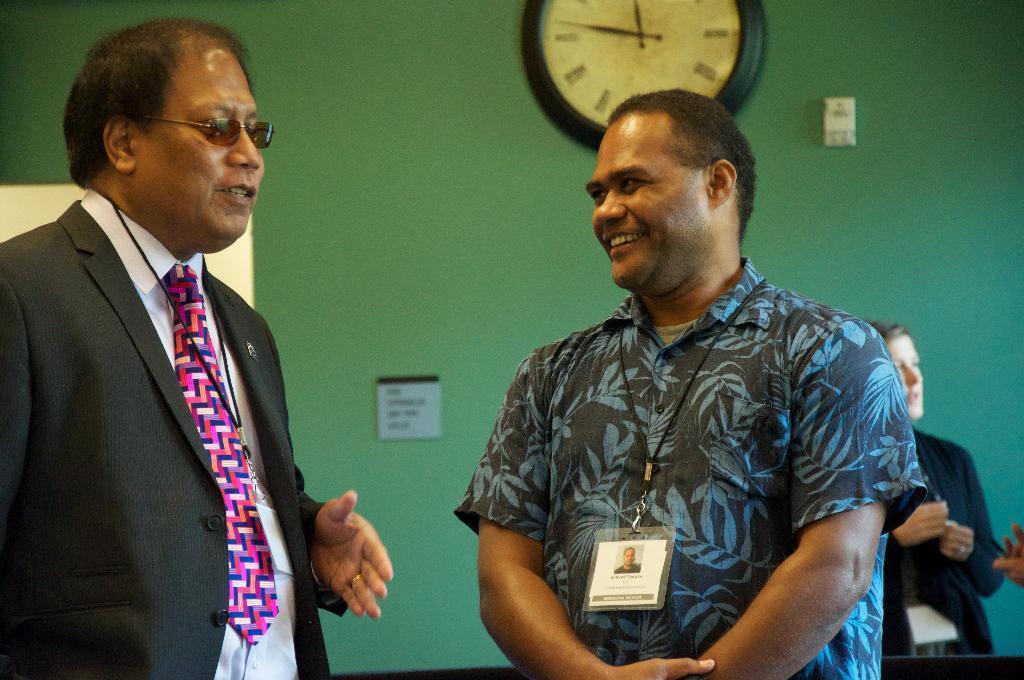Can you describe this image briefly? In this image I can see two persons standing, the person at left is wearing black blazer, white shirt and pink and blue color tie. In the background I can see the clock attached to the wall and the wall is in green color. 